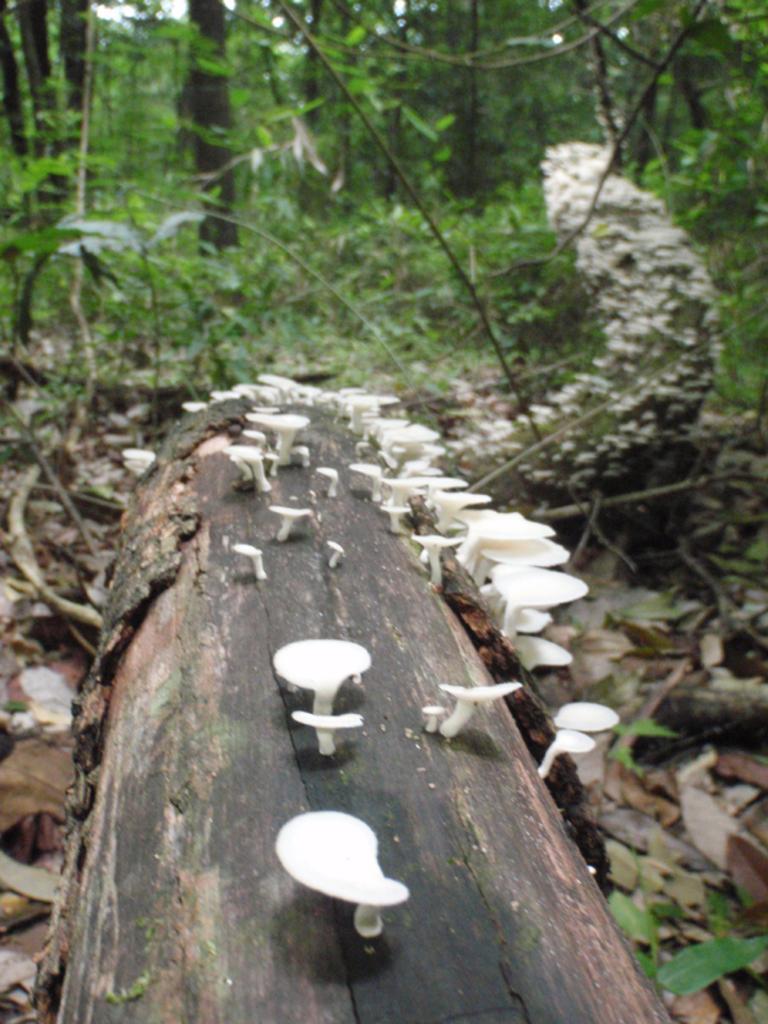In one or two sentences, can you explain what this image depicts? In this picture I can see there is a tree trunk and there are few mushrooms, there are a few plants and trees in the backdrop and the backdrop of the image is blurred. 